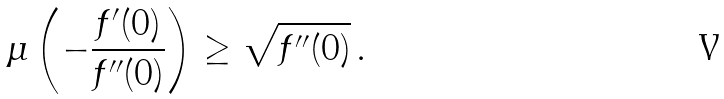<formula> <loc_0><loc_0><loc_500><loc_500>\mu \left ( - \frac { f ^ { \prime } ( 0 ) } { f ^ { \prime \prime } ( 0 ) } \right ) \geq \sqrt { f ^ { \prime \prime } ( 0 ) } \, .</formula> 